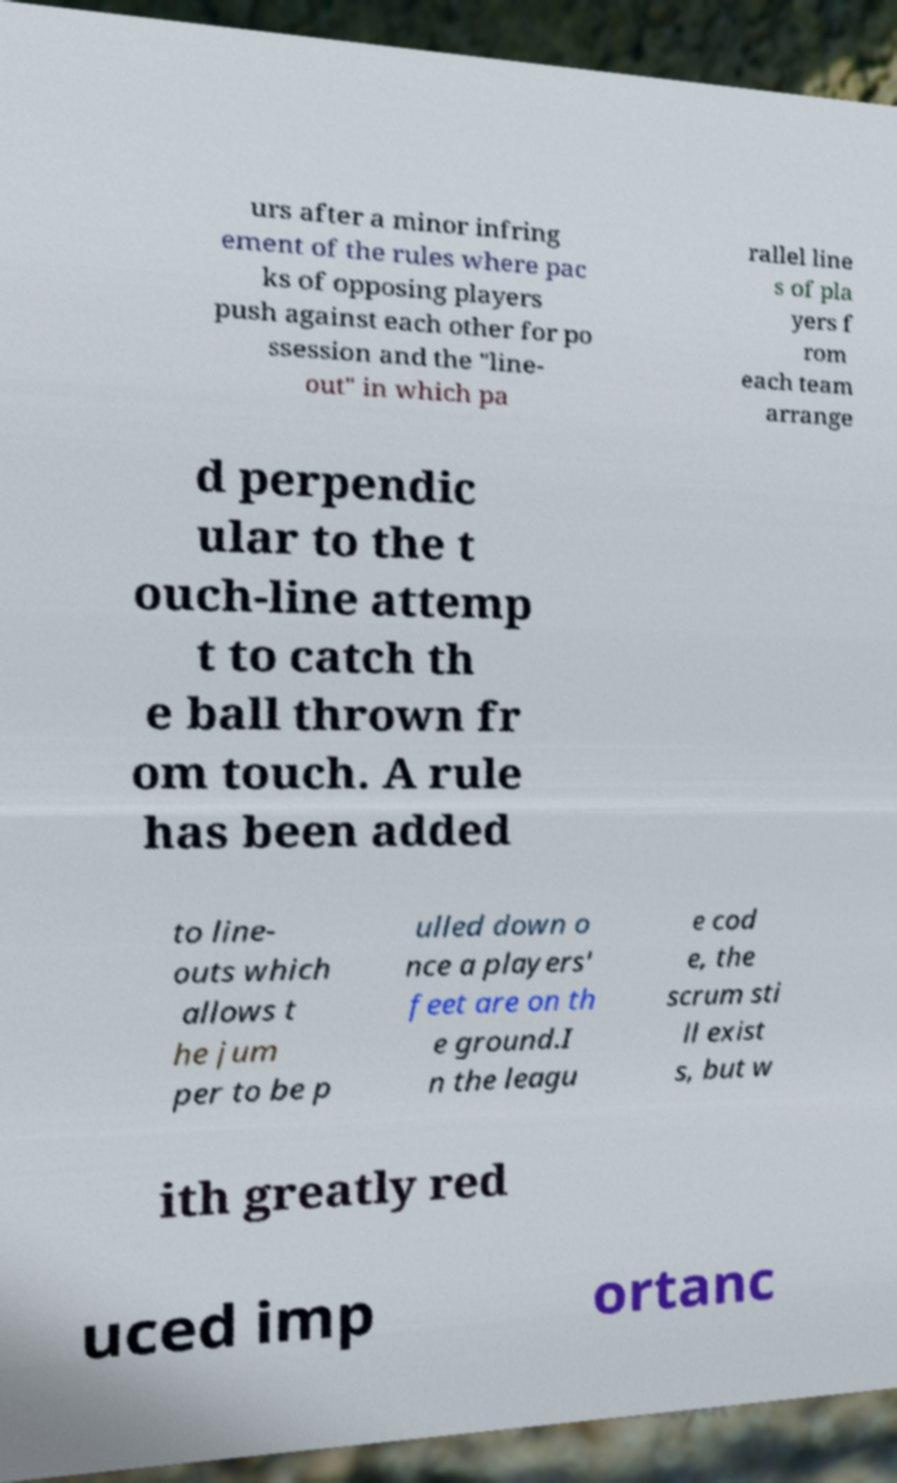Can you accurately transcribe the text from the provided image for me? urs after a minor infring ement of the rules where pac ks of opposing players push against each other for po ssession and the "line- out" in which pa rallel line s of pla yers f rom each team arrange d perpendic ular to the t ouch-line attemp t to catch th e ball thrown fr om touch. A rule has been added to line- outs which allows t he jum per to be p ulled down o nce a players' feet are on th e ground.I n the leagu e cod e, the scrum sti ll exist s, but w ith greatly red uced imp ortanc 